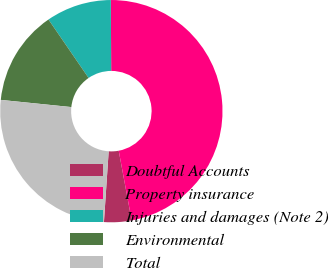<chart> <loc_0><loc_0><loc_500><loc_500><pie_chart><fcel>Doubtful Accounts<fcel>Property insurance<fcel>Injuries and damages (Note 2)<fcel>Environmental<fcel>Total<nl><fcel>3.99%<fcel>47.14%<fcel>9.5%<fcel>13.81%<fcel>25.55%<nl></chart> 